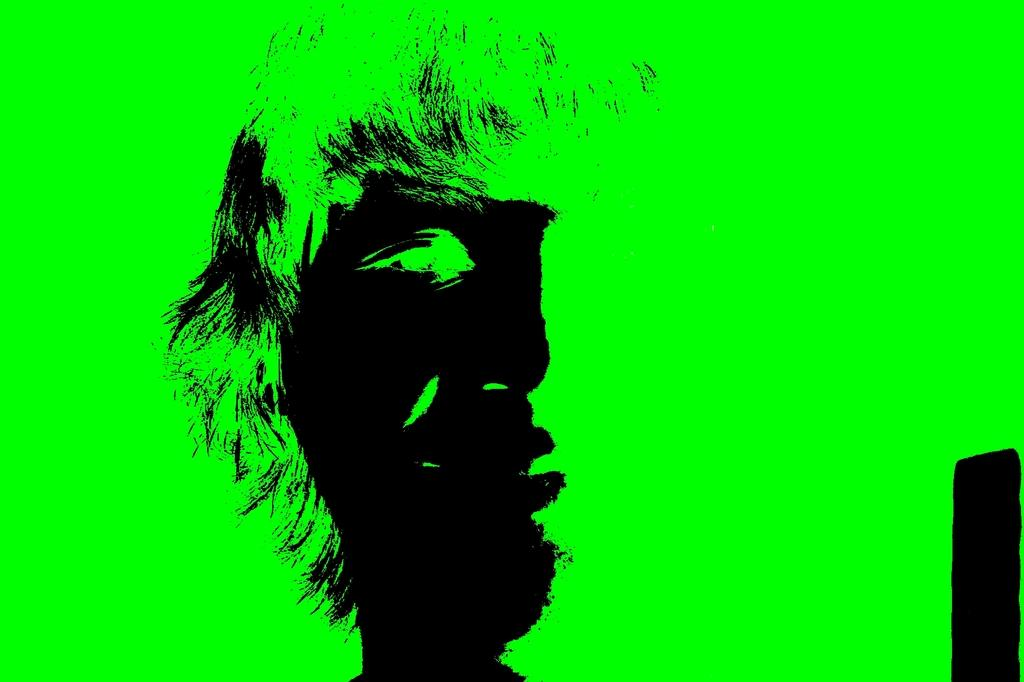What can be said about the nature of the image? The image is edited. Can you describe the main subject in the image? There is a person in the image. What color is the background of the image? The background of the image is green. What type of bear can be seen playing basketball in the image? There is no bear or basketball present in the image; it features a person with a green background. 